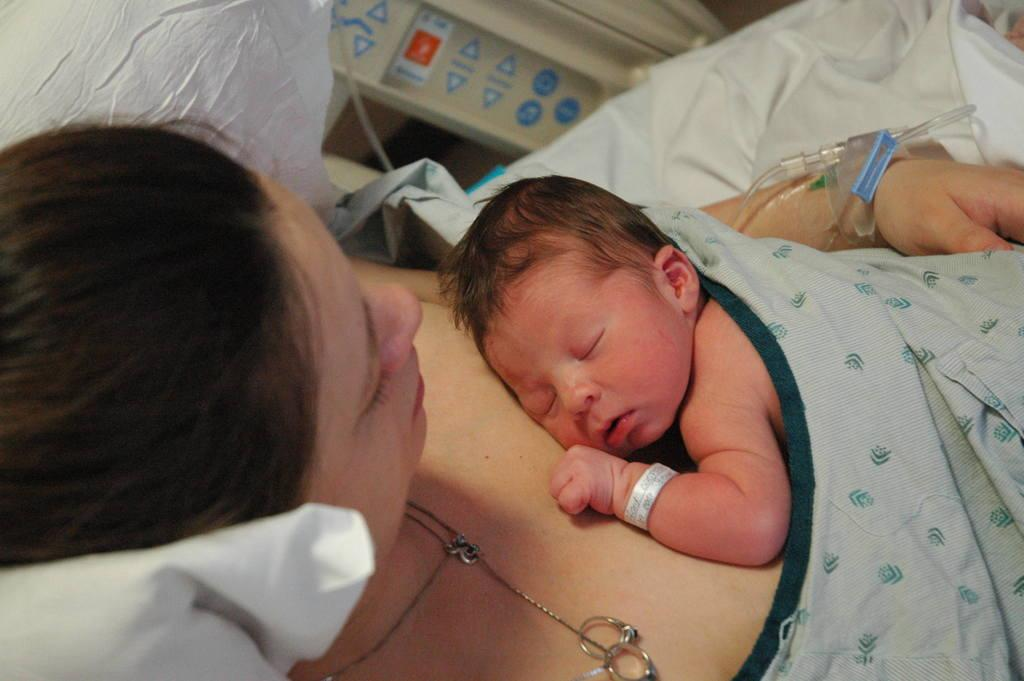What is the main subject of the image? There is a kid in the image. What is the kid doing in the image? The kid is lying on a woman. What can be seen in the image besides the kid and the woman? There is a pillow, clothes, rings, and a chain visible in the image. Are there any other objects present in the image? Yes, there are other objects in the image. Can you see any geese or hoses in the image? No, there are no geese or hoses present in the image. Are there any planes visible in the image? No, there are no planes visible in the image. 